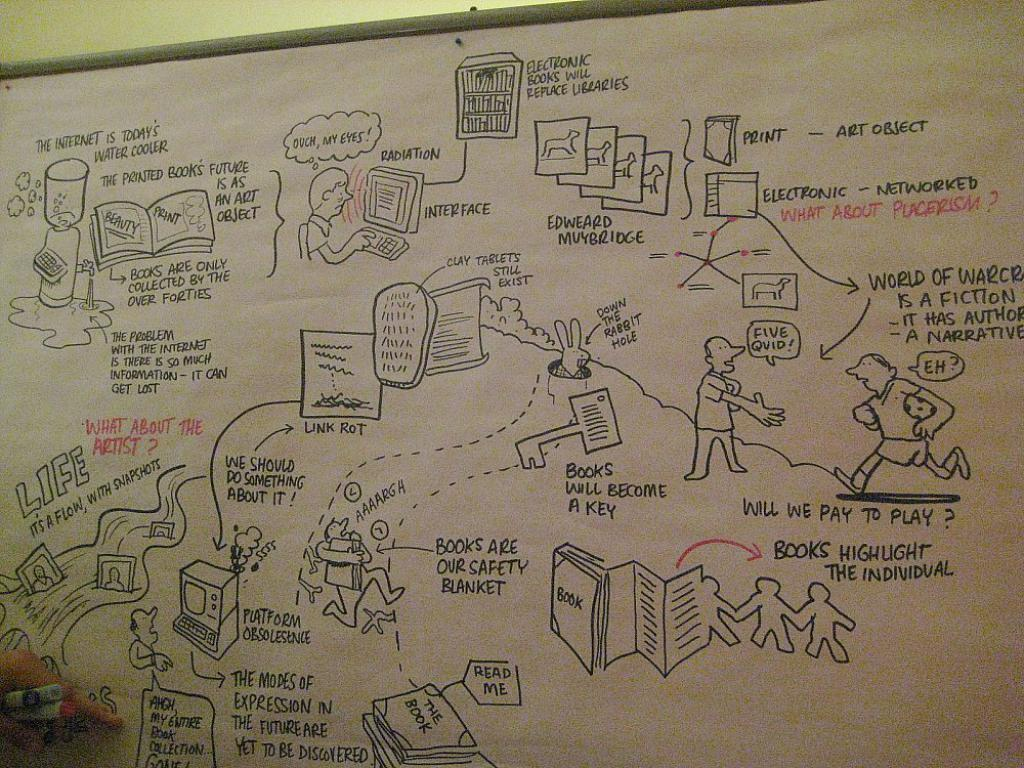<image>
Relay a brief, clear account of the picture shown. A white paper board has drawings to compare the internet to the water cooler. 